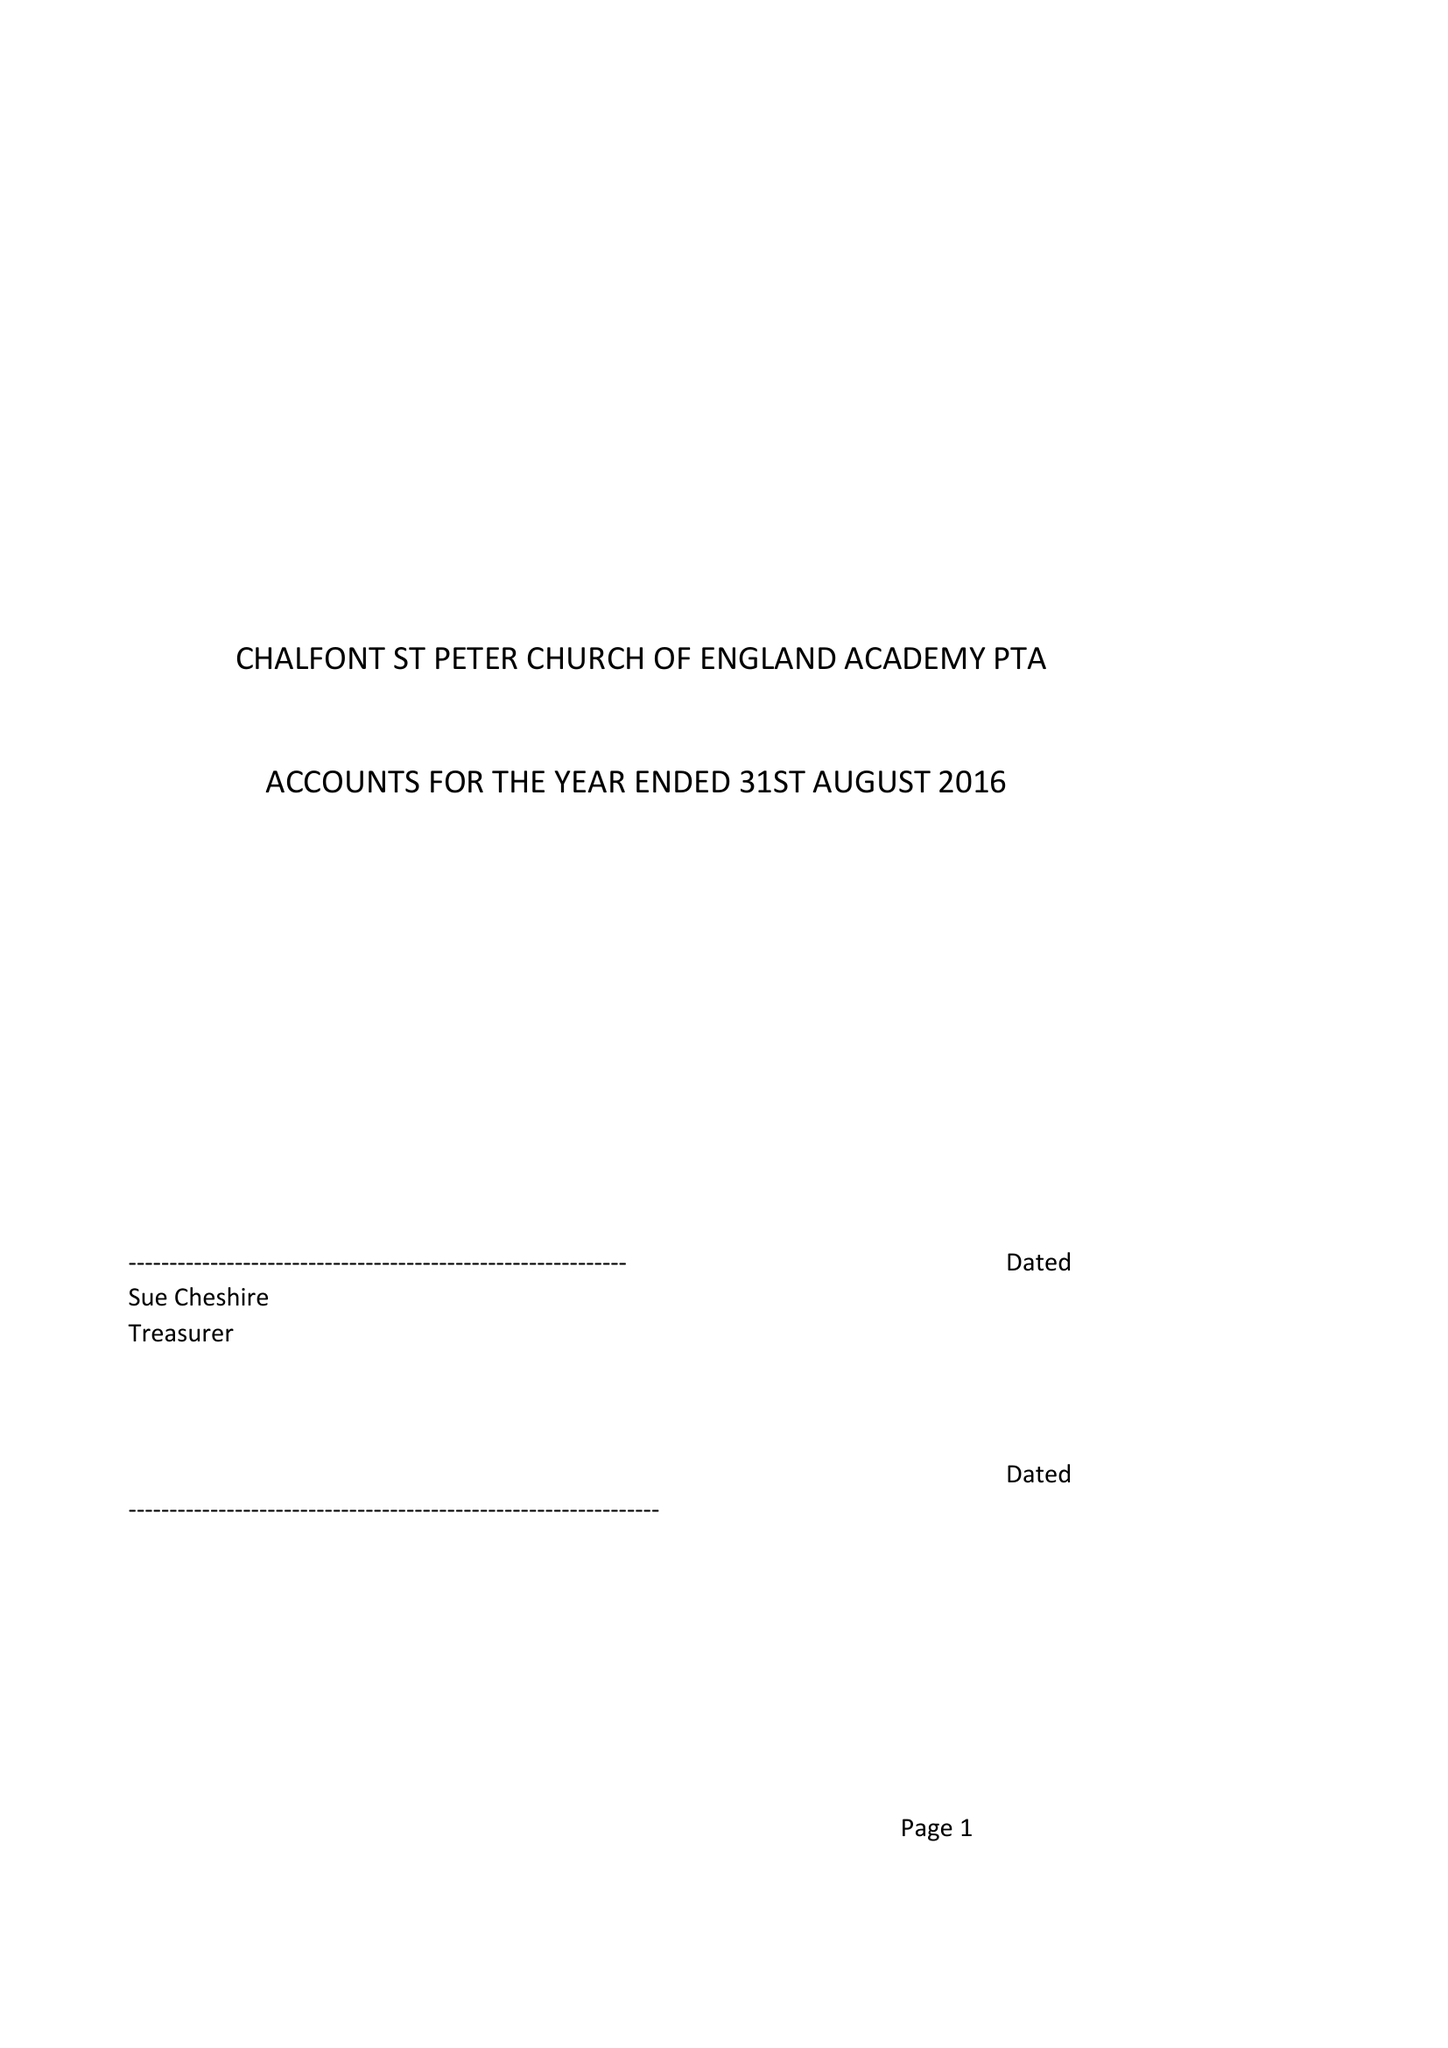What is the value for the charity_number?
Answer the question using a single word or phrase. 1035642 